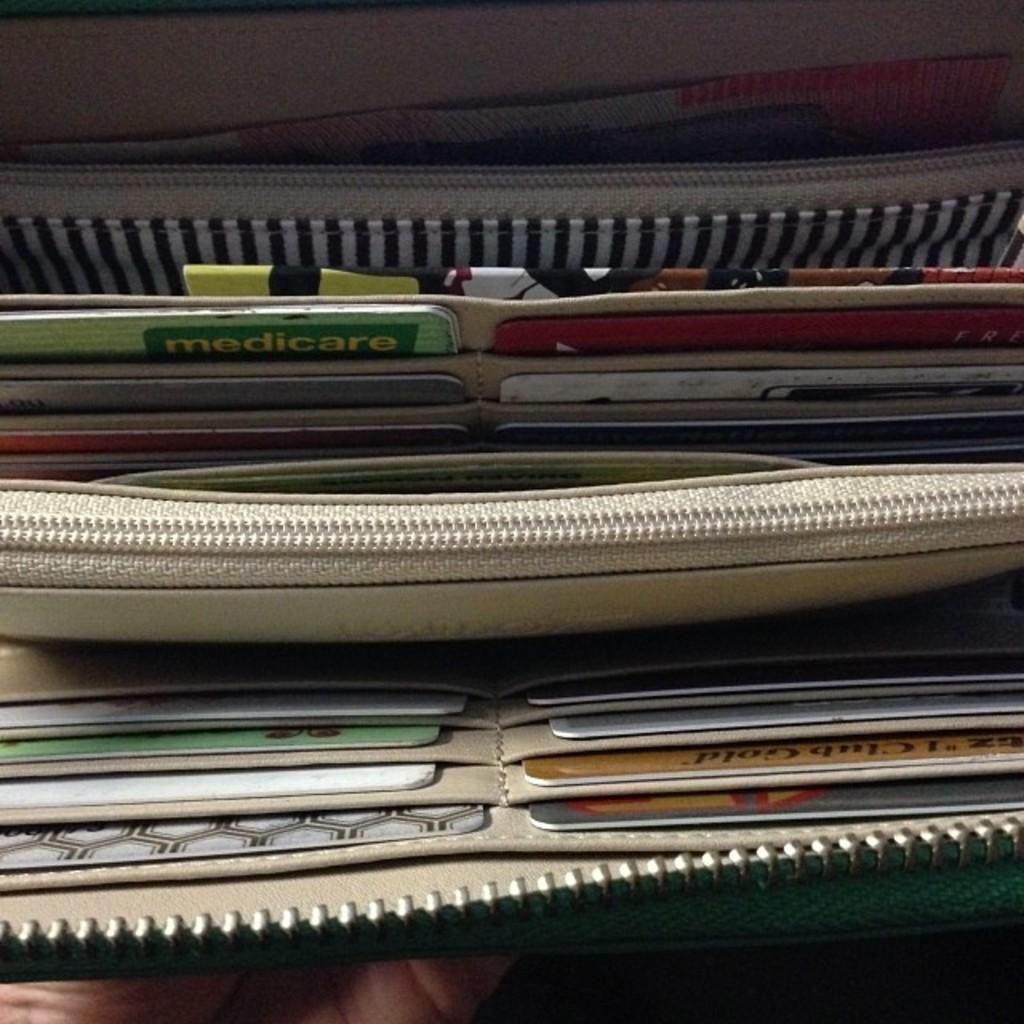How would you summarize this image in a sentence or two? In this wallet we can see different types of cards, zips and currency. Bottom of the image there is a person hand.  